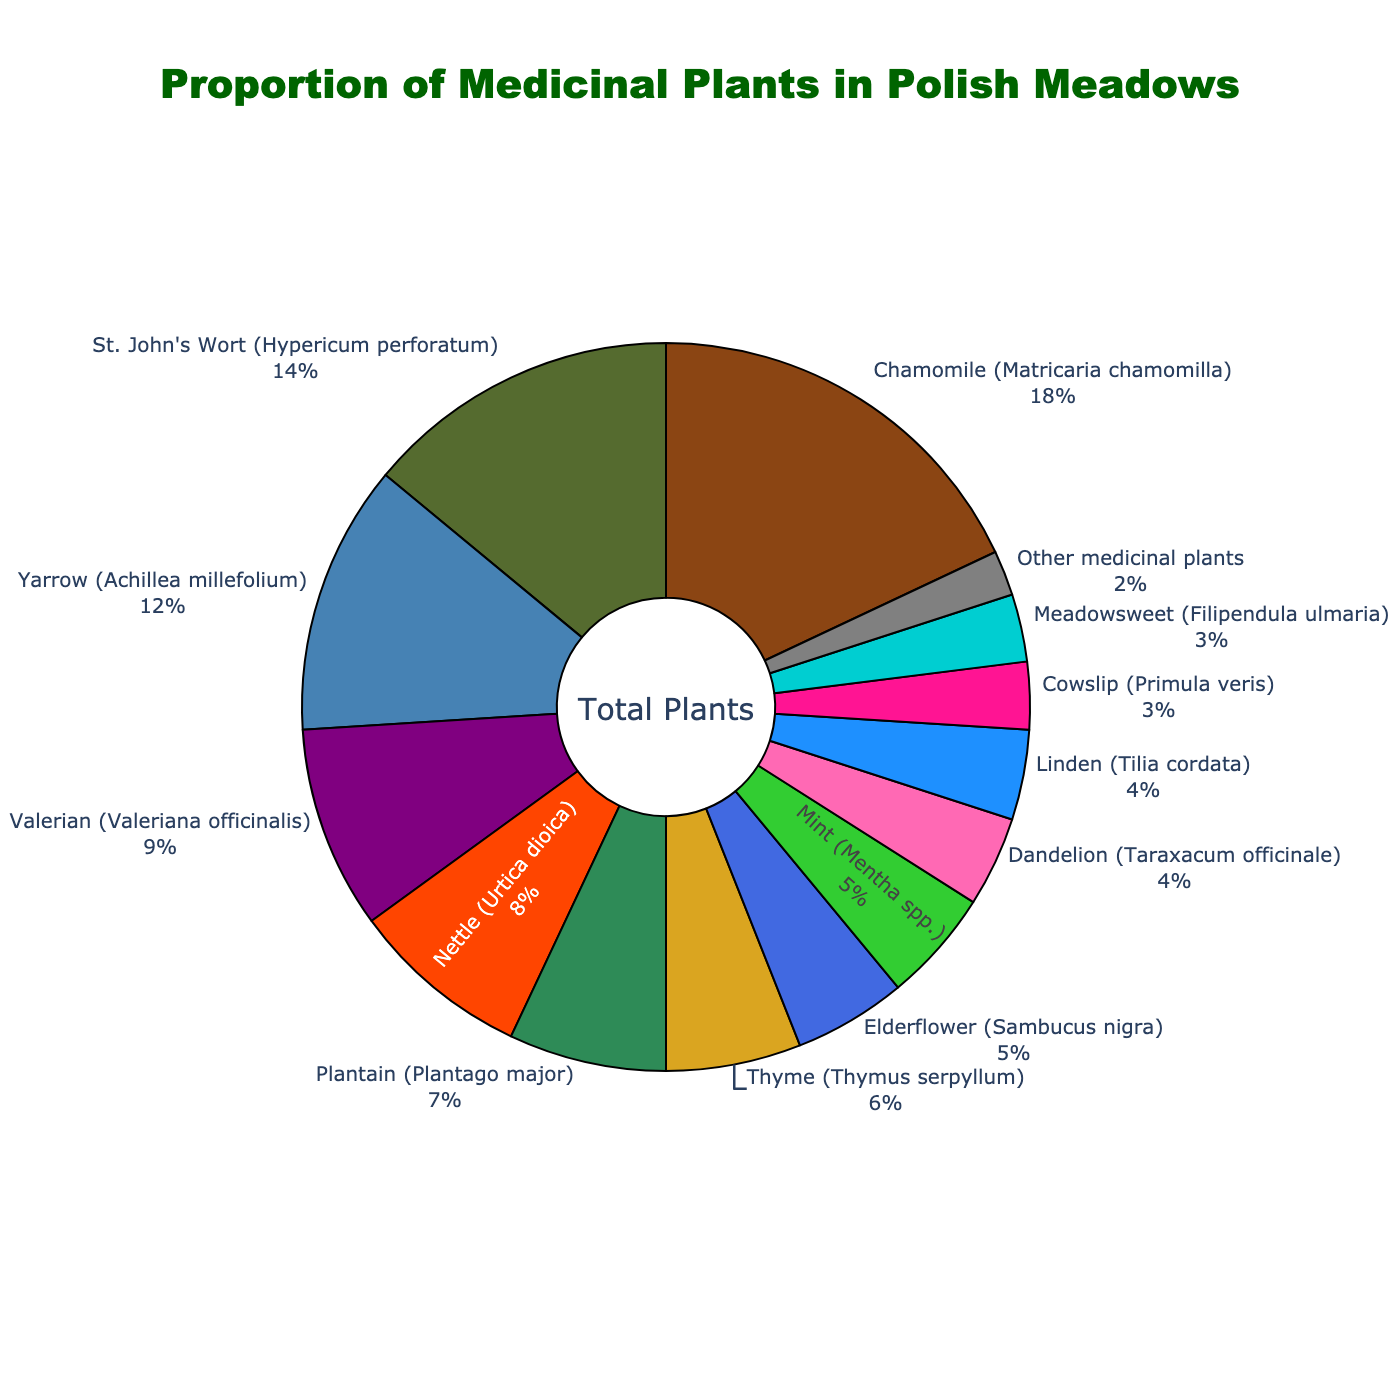what type of medicinal plant has the highest proportion in Polish meadows? By looking at the pie chart, the section with the Chamomile label is the largest. Therefore, Chamomile has the highest proportion.
Answer: Chamomile Which two medicinal plants have the smallest proportions? By looking at the pie chart, the sections labeled Meadowsweet and Cowslip are the smallest.
Answer: Meadowsweet and Cowslip What is the combined proportion of Chamomile, St. John's Wort, and Yarrow? Chamomile is 18%, St. John's Wort is 14%, and Yarrow is 12%. Sum these values: 18 + 14 + 12 = 44.
Answer: 44% How does the proportion of Nettle compare to that of Plantain? The pie chart shows that Nettle is 8% and Plantain is 7%. Since 8% > 7%, Nettle has a higher proportion than Plantain.
Answer: Nettle has a higher proportion Which medicinal plant has a greater proportion, Thyme or Elderflower, and by how much? Thyme is 6% and Elderflower is 5%. The difference is 6 - 5 = 1%, so Thyme has a 1% greater proportion than Elderflower.
Answer: Thyme by 1% What are the top three medicinal plants by proportion in Polish meadows? By looking at the three largest sections in the pie chart, it is clear that Chamomile (18%), St. John's Wort (14%), and Yarrow (12%) are the top three.
Answer: Chamomile, St. John's Wort, and Yarrow Which has a lower proportion: Mint or Dandelion? By looking at the pie chart, Mint has 5%, and Dandelion has 4%. Since 4% < 5%, Dandelion has a lower proportion than Mint.
Answer: Dandelion Express the proportion of the plants that have a percentage less than 5% as a single value. Plants with less than 5% are Dandelion (4%), Linden (4%), Cowslip (3%), and Meadowsweet (3%). Sum these values: 4 + 4 + 3 + 3 = 14.
Answer: 14% How does the combined proportion of Thyme and Elderflower compare to that of Valerian? Thyme is 6% and Elderflower is 5%. Combined, they are 6 + 5 = 11%. Valerian is 9%. Since 11% > 9%, the combined proportion of Thyme and Elderflower is higher.
Answer: Combined proportion is higher than Valerian What percentage of the chart does "Other medicinal plants" occupy, and which other plant shares the same color in the pie chart? "Other medicinal plants" occupy 2%. By checking the colors, Elderflower and "Other medicinal plants" have the same color in the pie chart.
Answer: 2%, Elderflower 